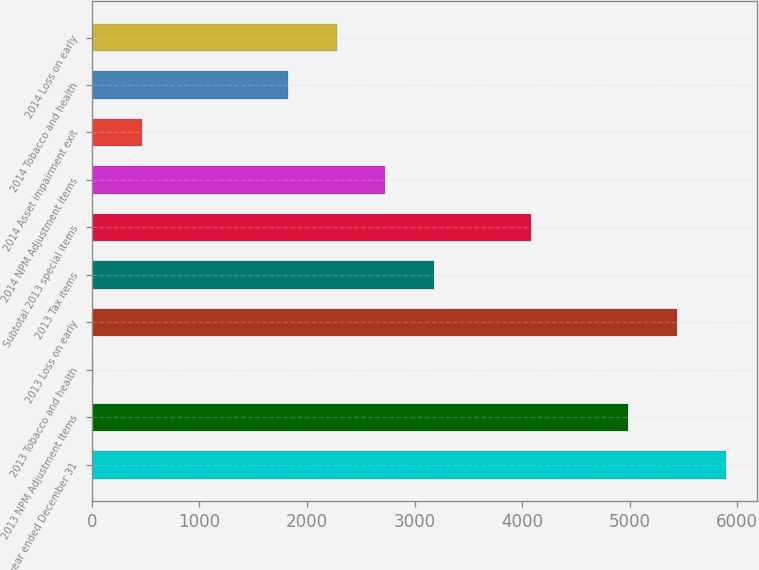<chart> <loc_0><loc_0><loc_500><loc_500><bar_chart><fcel>For the year ended December 31<fcel>2013 NPM Adjustment Items<fcel>2013 Tobacco and health<fcel>2013 Loss on early<fcel>2013 Tax items<fcel>Subtotal 2013 special items<fcel>2014 NPM Adjustment Items<fcel>2014 Asset impairment exit<fcel>2014 Tobacco and health<fcel>2014 Loss on early<nl><fcel>5891.3<fcel>4987.1<fcel>14<fcel>5439.2<fcel>3178.7<fcel>4082.9<fcel>2726.6<fcel>466.1<fcel>1822.4<fcel>2274.5<nl></chart> 